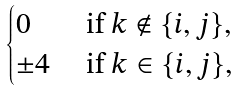Convert formula to latex. <formula><loc_0><loc_0><loc_500><loc_500>\begin{cases} 0 & \text { if } k \notin \{ i , j \} , \\ \pm 4 & \text { if } k \in \{ i , j \} , \end{cases}</formula> 